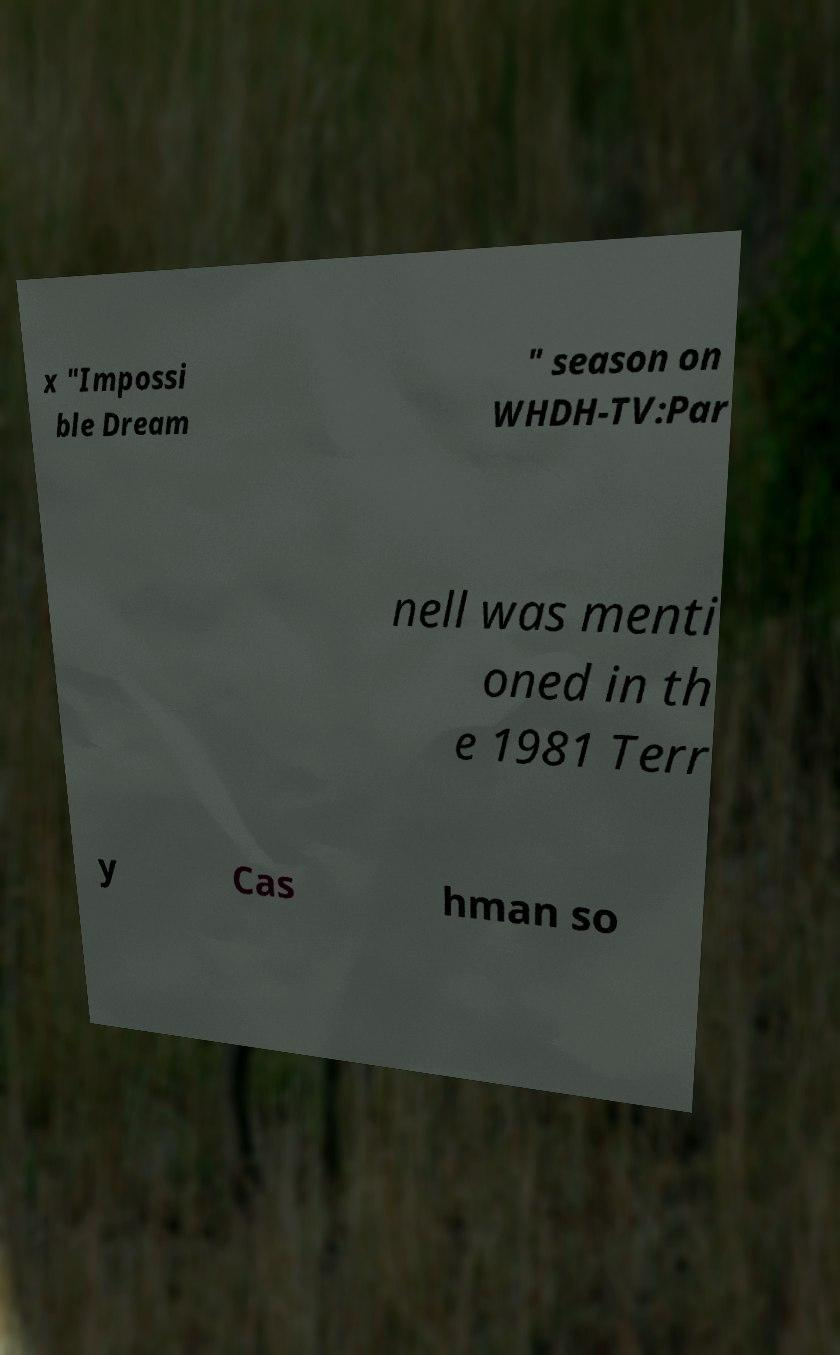For documentation purposes, I need the text within this image transcribed. Could you provide that? x "Impossi ble Dream " season on WHDH-TV:Par nell was menti oned in th e 1981 Terr y Cas hman so 